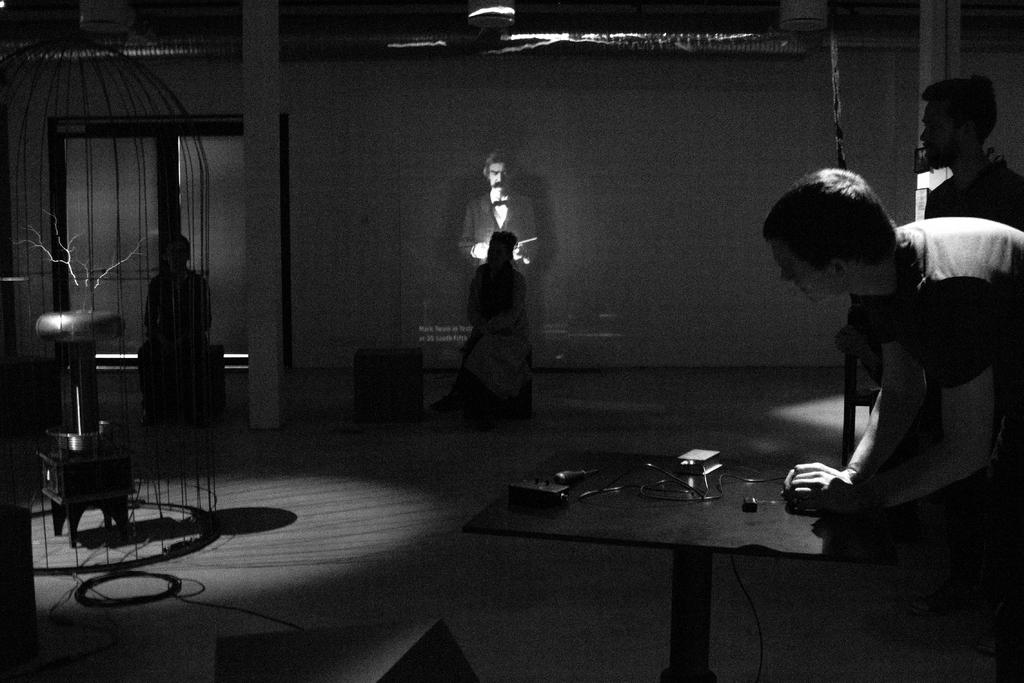What is the man in the image doing? There is a man standing in the image. What is in front of the man? There is a table in front of the man. What can be seen in the image besides the man and the table? There is a wire visible in the image. Who else is present in the image? There is a woman sitting in the image. What is the background of the image? There is a wall in the image. What type of wilderness can be seen through the window in the image? There is no window present in the image, so it is not possible to see any wilderness. 